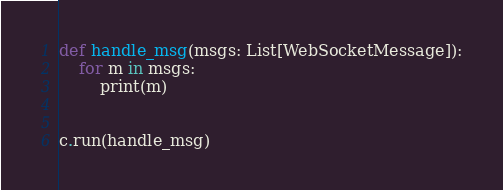Convert code to text. <code><loc_0><loc_0><loc_500><loc_500><_Python_>def handle_msg(msgs: List[WebSocketMessage]):
    for m in msgs:
        print(m)


c.run(handle_msg)
</code> 